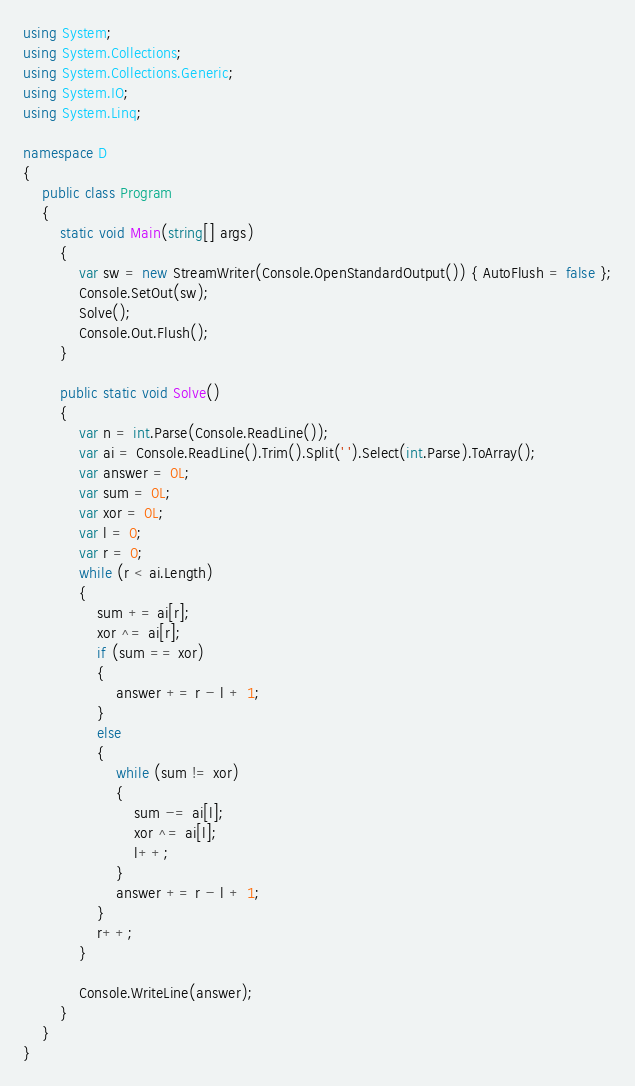<code> <loc_0><loc_0><loc_500><loc_500><_C#_>using System;
using System.Collections;
using System.Collections.Generic;
using System.IO;
using System.Linq;

namespace D
{
    public class Program
    {
        static void Main(string[] args)
        {
            var sw = new StreamWriter(Console.OpenStandardOutput()) { AutoFlush = false };
            Console.SetOut(sw);
            Solve();
            Console.Out.Flush();
        }

        public static void Solve()
        {
            var n = int.Parse(Console.ReadLine());
            var ai = Console.ReadLine().Trim().Split(' ').Select(int.Parse).ToArray();
            var answer = 0L;
            var sum = 0L;
            var xor = 0L;
            var l = 0;
            var r = 0;
            while (r < ai.Length)
            {
                sum += ai[r];
                xor ^= ai[r];
                if (sum == xor)
                {
                    answer += r - l + 1;
                }
                else
                {
                    while (sum != xor)
                    {
                        sum -= ai[l];
                        xor ^= ai[l];
                        l++;
                    }
                    answer += r - l + 1;
                }
                r++;
            }

            Console.WriteLine(answer);
        }
    }
}
</code> 